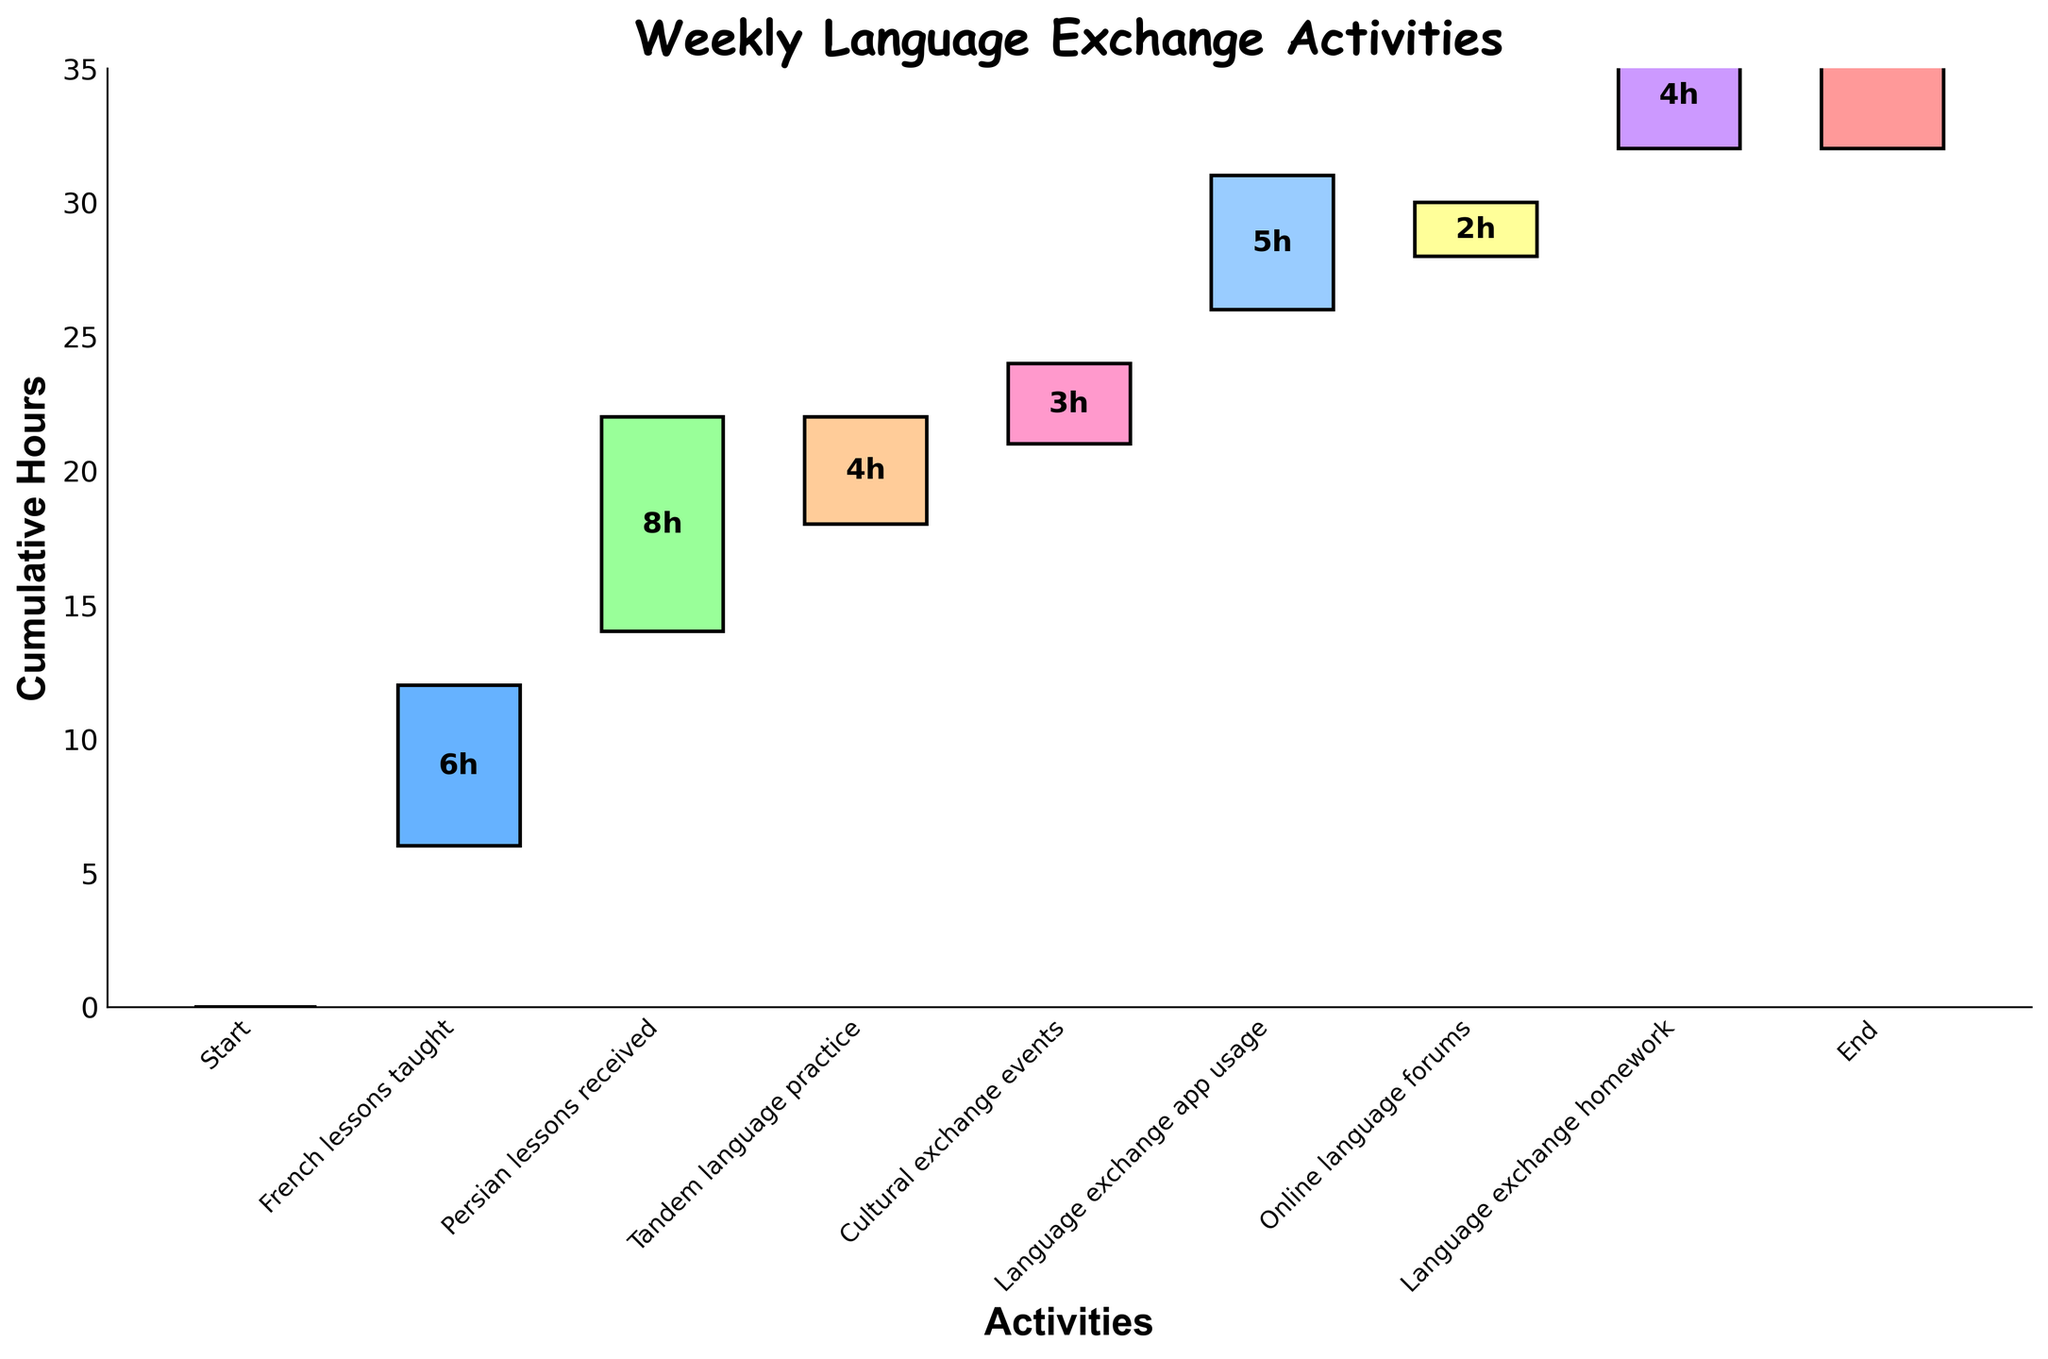What's the title of the figure? The title is displayed at the top of the figure. It describes the overall content.
Answer: Weekly Language Exchange Activities What are the labels for the x-axis and y-axis? The x-axis label describes the type of activities, and the y-axis label indicates the cumulative hours spent.
Answer: Activities and Cumulative Hours How many hours are dedicated to 'French lessons taught'? Find the bar labeled 'French lessons taught' on the x-axis and read the hours value written on it.
Answer: 6 hours What is the total number of activities listed (excluding 'Start' and 'End')? Count the bars excluding 'Start' and 'End' since they represent cumulative points rather than activities.
Answer: 6 How many hours are spent more on 'Persian lessons received' than 'French lessons taught'? Subtract the hours for 'French lessons taught' from 'Persian lessons received'.
Answer: 2 hours (8 - 6) Which activity has the least number of hours allocated? Identify the smallest bar height among the activities (excluding 'Start' and 'End').
Answer: Online language forums What is the cumulative time spent on 'Tandem language practice', 'Cultural exchange events', and 'Language exchange app usage'? Sum the hours of 'Tandem language practice' (4), 'Cultural exchange events' (3), and 'Language exchange app usage' (5).
Answer: 12 hours (4 + 3 + 5) Which activity adds the most to the cumulative hours? Find the activity with the tallest bar.
Answer: Persian lessons received Is the time spent on 'Language exchange app usage' greater than the time on 'French lessons taught'? Compare the bar heights or the hours values for these activities.
Answer: Yes What's the sum of all hours dedicated to different activities (excluding 'Start' and 'End')? Sum the hours from all activities (6+8+4+3+5+2+4).
Answer: 32 hours 